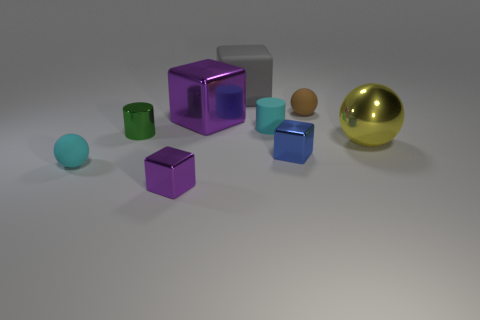Is the material of the sphere behind the small rubber cylinder the same as the cyan ball?
Make the answer very short. Yes. How many blocks are either small objects or blue metal things?
Ensure brevity in your answer.  2. There is a small metal object that is both behind the cyan sphere and left of the big purple metal block; what shape is it?
Provide a succinct answer. Cylinder. What color is the cylinder to the left of the tiny cyan object behind the thing on the right side of the small brown matte thing?
Provide a short and direct response. Green. Is the number of big gray matte cubes that are in front of the matte cylinder less than the number of big brown cylinders?
Your answer should be very brief. No. There is a cyan thing that is on the right side of the large gray matte cube; is its shape the same as the small purple metal object in front of the small cyan ball?
Provide a short and direct response. No. What number of objects are large shiny things that are right of the brown ball or large blocks?
Your response must be concise. 3. What material is the sphere that is the same color as the rubber cylinder?
Your answer should be very brief. Rubber. There is a purple object left of the big purple metal block that is in front of the tiny brown thing; is there a tiny rubber ball behind it?
Give a very brief answer. Yes. Is the number of small blue shiny things that are to the left of the brown rubber object less than the number of small green objects that are behind the big gray thing?
Your response must be concise. No. 